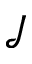Convert formula to latex. <formula><loc_0><loc_0><loc_500><loc_500>\mathcal { J }</formula> 